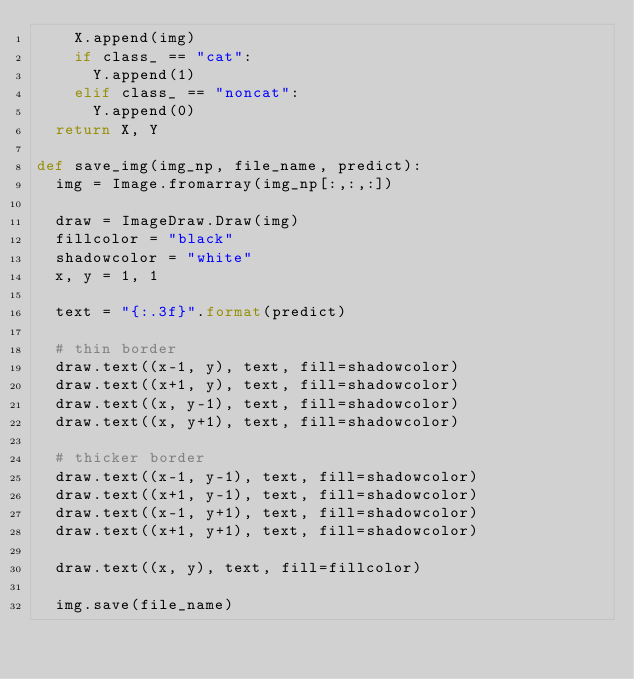Convert code to text. <code><loc_0><loc_0><loc_500><loc_500><_Python_>		X.append(img)
		if class_ == "cat":
			Y.append(1)
		elif class_ == "noncat":
			Y.append(0)
	return X, Y

def save_img(img_np, file_name, predict):
	img = Image.fromarray(img_np[:,:,:])

	draw = ImageDraw.Draw(img)
	fillcolor = "black"
	shadowcolor = "white"
	x, y = 1, 1

	text = "{:.3f}".format(predict)

	# thin border
	draw.text((x-1, y), text, fill=shadowcolor)
	draw.text((x+1, y), text, fill=shadowcolor)
	draw.text((x, y-1), text, fill=shadowcolor)
	draw.text((x, y+1), text, fill=shadowcolor)

	# thicker border
	draw.text((x-1, y-1), text, fill=shadowcolor)
	draw.text((x+1, y-1), text, fill=shadowcolor)
	draw.text((x-1, y+1), text, fill=shadowcolor)
	draw.text((x+1, y+1), text, fill=shadowcolor)

	draw.text((x, y), text, fill=fillcolor)

	img.save(file_name)</code> 